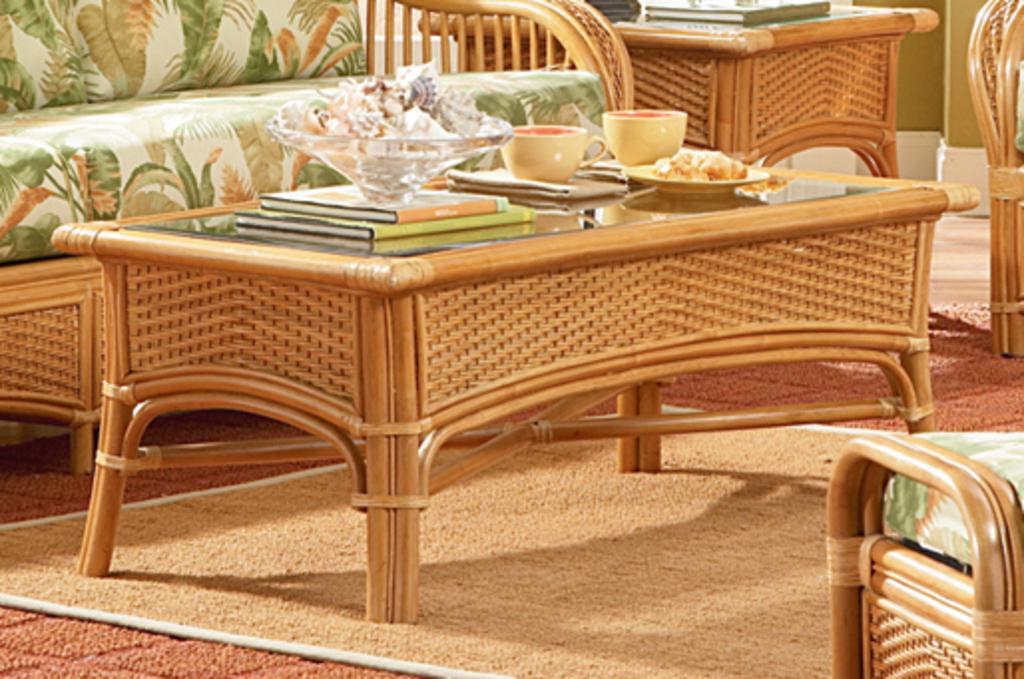In one or two sentences, can you explain what this image depicts? In this picture there is sofa at the top left side of the image and there are chairs on the right side of the image, there is a table in the center of the image, which contains cups, books, and a plate on it, there is a desk at the top side of the image, which contains a book on it, there is a rug on the floor. 